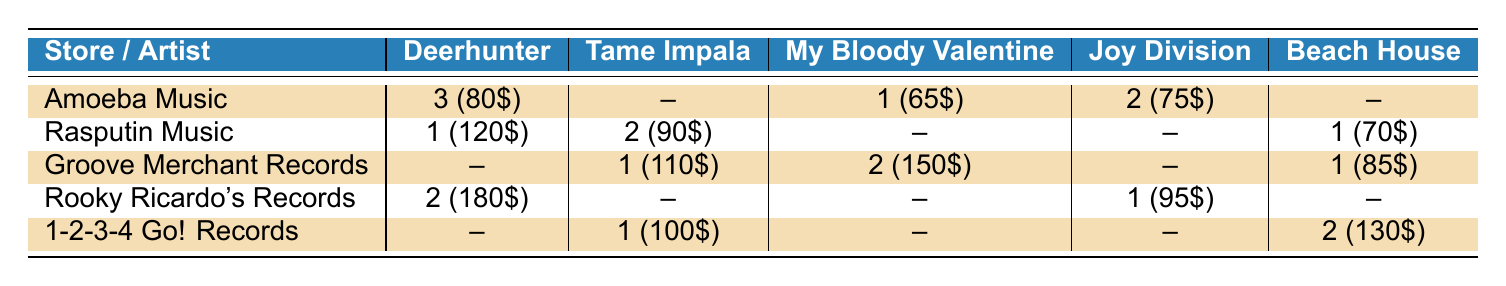What is the total inventory of Deerhunter vinyl records across all stores? To find the total inventory, we need to sum the values in the Deerhunter column: 3 (Amoeba) + 1 (Rasputin) + 0 (Groove Merchant) + 2 (Rooky Ricardo's) + 0 (1-2-3-4 Go!) = 6.
Answer: 6 Which store has the most records of My Bloody Valentine? Looking at the My Bloody Valentine column, Amoeba Music has 1, Rasputin Music has 0, Groove Merchant has 2, Rooky Ricardo's has 0, and 1-2-3-4 Go! has 0. The highest value is 2 from Groove Merchant Records.
Answer: Groove Merchant Records Does Rasputin Music have any records of Joy Division? In the Joy Division column, the value for Rasputin Music is 0. Therefore, Rasputin does not have any records of Joy Division.
Answer: No What is the average price of Beach House records across all stores? The prices for Beach House records are: -- (Amoeba, not available), 70 (Rasputin), 85 (Groove Merchant), -- (Rooky Ricardo's, not available), and 130 (1-2-3-4 Go!). Only considering available prices: 70 + 85 + 130 = 285. Dividing by 3 (the number of stores with records) gives us an average price of 285/3 = 95.
Answer: 95 Which store has the highest rarity score for Tame Impala vinyl records? The rarity scores for Tame Impala vinyl records at each store are: Amoeba (0), Rasputin (7), Groove Merchant (8), Rooky Ricardo's (0), and 1-2-3-4 Go! (7). The highest score is 8 from Groove Merchant Records.
Answer: Groove Merchant Records What is the total inventory of vinyl records across all genres in Amoeba Music? The total inventory at Amoeba Music for all genres is 3 (Deerhunter) + 0 (Tame Impala) + 1 (My Bloody Valentine) + 2 (Joy Division) + 0 (Beach House) = 6.
Answer: 6 Which artist has the highest average price among all stores? To calculate the average price for each artist, add up the prices per artist: Deerhunter: (80 + 120 + 0 + 180 + 0) = 380, the average is 380/4 = 95. Tame Impala: (0 + 90 + 110 + 0 + 100) = 300, average is 300/4 = 75. My Bloody Valentine: (65 + 0 + 150 + 0 + 0) = 215, average is 215/2 = 107.5. Joy Division: (75 + 0 + 0 + 95 + 0) = 170, average is 170/2 = 85. Beach House: (0 + 70 + 85 + 0 + 130) = 285, average is 285/3 = 95. The highest average price is 107.5 for My Bloody Valentine.
Answer: My Bloody Valentine Is there any store that has no inventory of vintage vinyl records for Psychedelic genre? In the Psychedelic genre column, Amoeba has 0, Rasputin has 2, Groove Merchant has 1, Rooky Ricardo's has 0, and 1-2-3-4 Go! has 1. There are stores (Amoeba and Rooky Ricardo's) that have no inventory for this genre.
Answer: Yes 